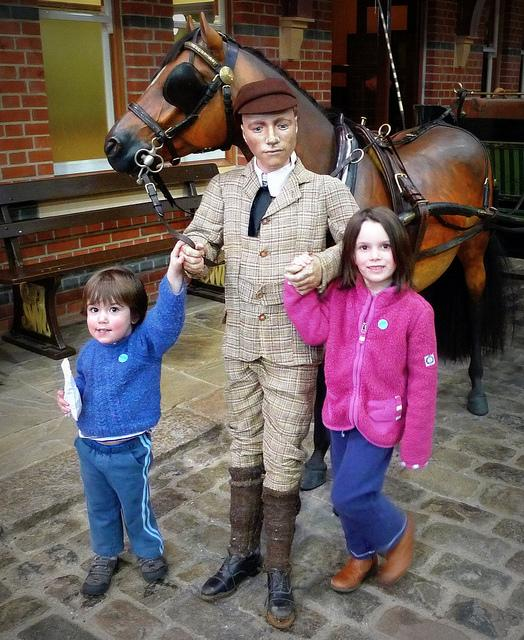What type of material makes up a majority of the construction in the area? brick 